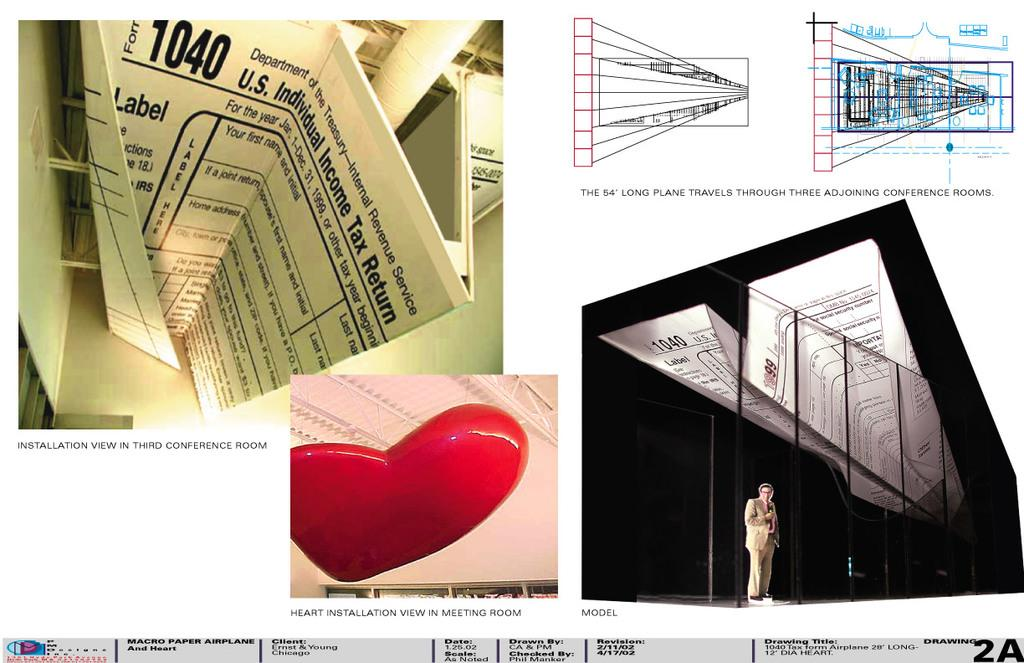<image>
Render a clear and concise summary of the photo. A 1040 U.S Tax form is folded in half on a table 